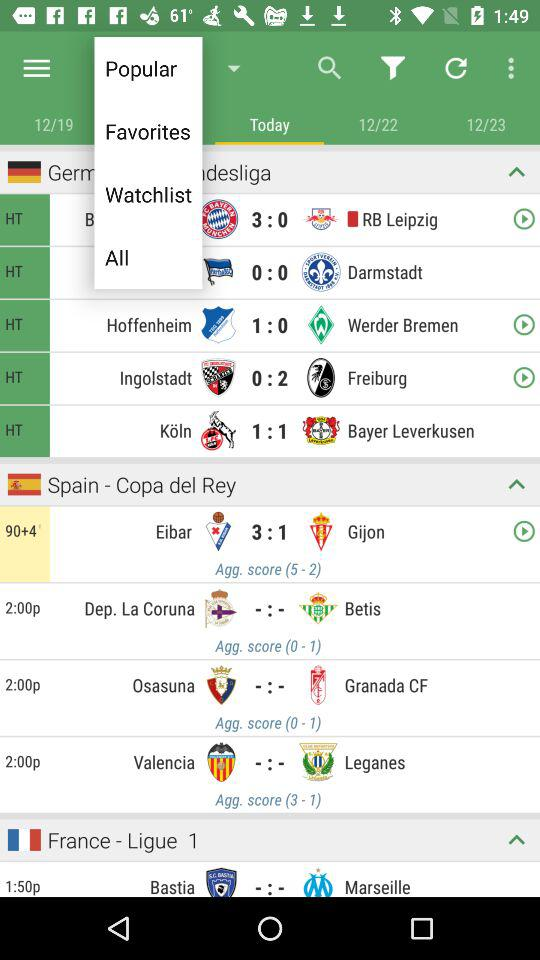What is the date and time of the match between "Eibar" and "Gijon"? The date and time of the match between "Eibar" and "Gijon" are Wednesday, December 21, 2016 and 12:00 PM respectively. 